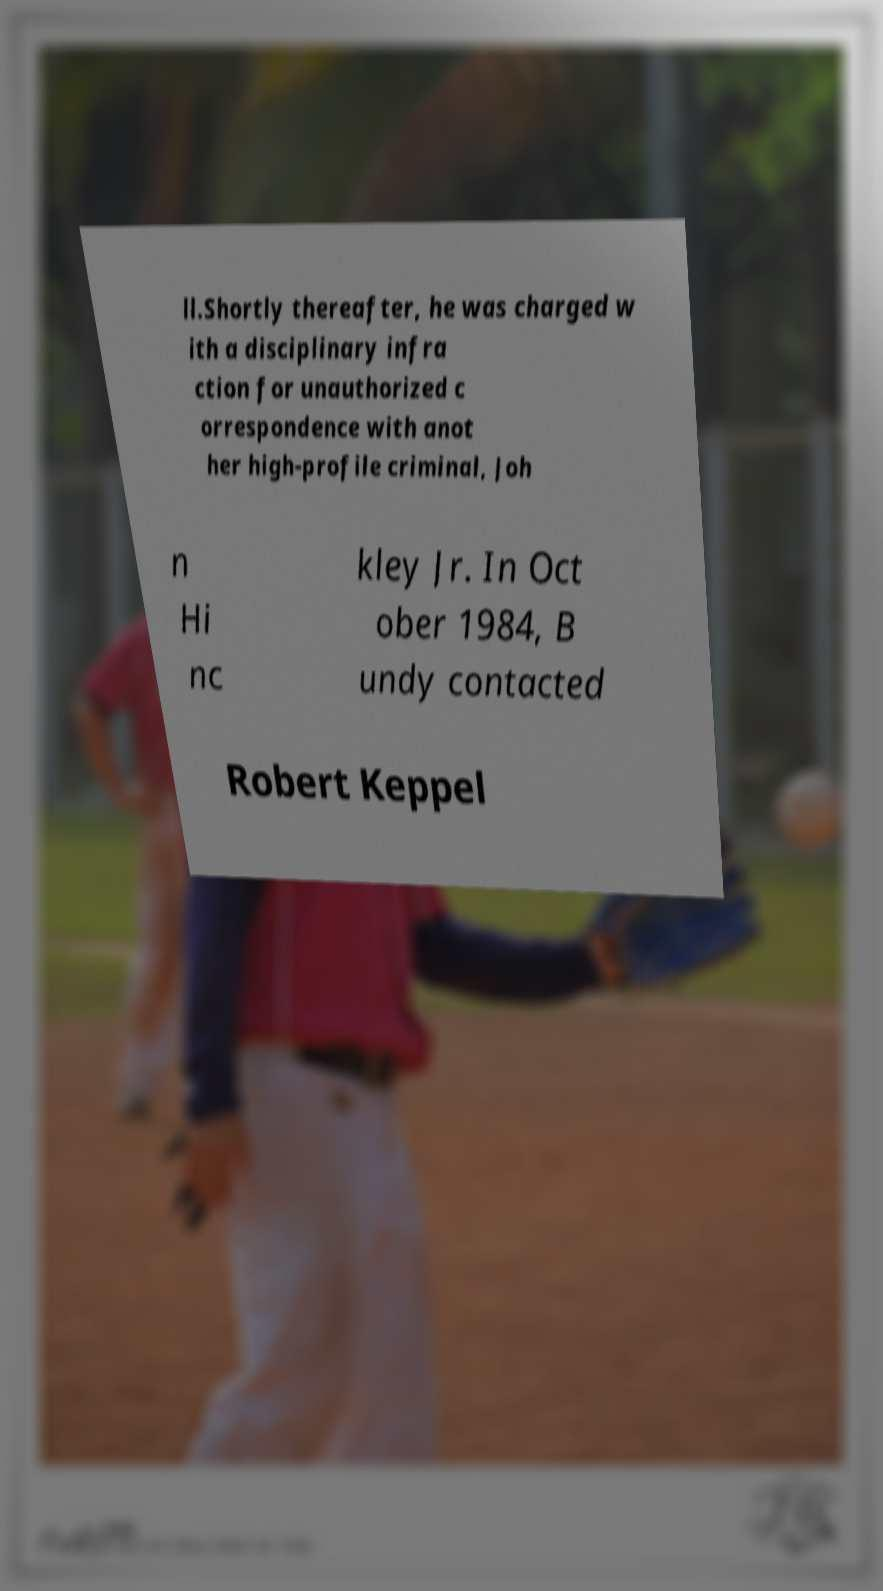Could you assist in decoding the text presented in this image and type it out clearly? ll.Shortly thereafter, he was charged w ith a disciplinary infra ction for unauthorized c orrespondence with anot her high-profile criminal, Joh n Hi nc kley Jr. In Oct ober 1984, B undy contacted Robert Keppel 